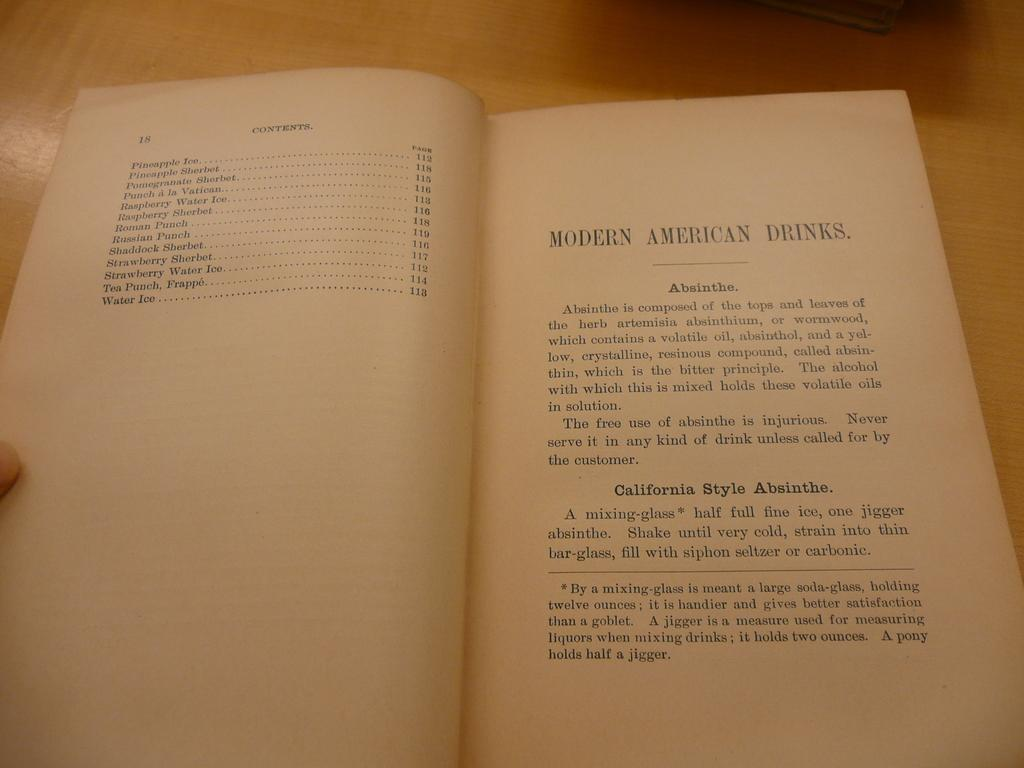<image>
Summarize the visual content of the image. A book sitting on a table is open to a page that reads Modern American Drinks. 